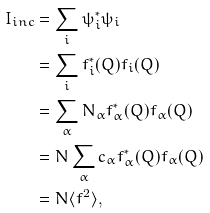<formula> <loc_0><loc_0><loc_500><loc_500>I _ { i n c } & = \sum _ { i } \psi _ { i } ^ { * } \psi _ { i } \\ & = \sum _ { i } f _ { i } ^ { * } ( Q ) f _ { i } ( Q ) \\ & = \sum _ { \alpha } N _ { \alpha } f _ { \alpha } ^ { * } ( Q ) f _ { \alpha } ( Q ) \\ & = N \sum _ { \alpha } c _ { \alpha } f _ { \alpha } ^ { * } ( Q ) f _ { \alpha } ( Q ) \\ & = N \langle f ^ { 2 } \rangle ,</formula> 